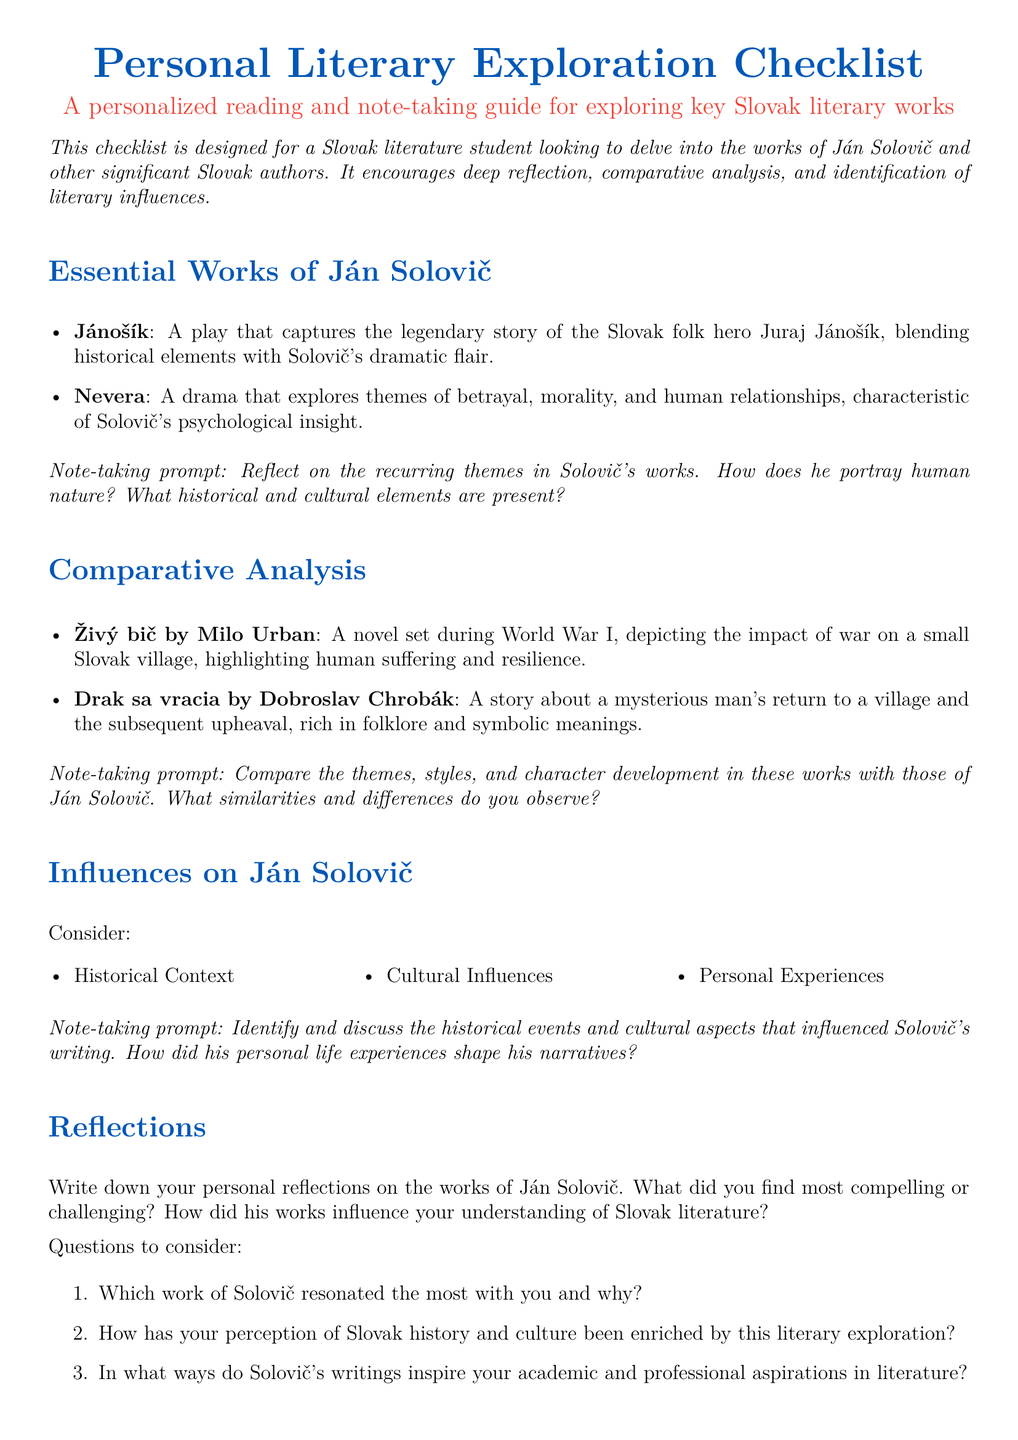What are the titles of Ján Solovič's essential works? The checklist lists two essential works by Ján Solovič: "Jánošík" and "Nevera."
Answer: "Jánošík, Nevera" What themes does "Nevera" explore? The checklist mentions that "Nevera" explores themes of betrayal, morality, and human relationships.
Answer: Betrayal, morality, human relationships Who is the author of "Živý bič"? The checklist provides the name of the author of "Živý bič," which is Milo Urban.
Answer: Milo Urban What historical event is the backdrop for "Živý bič"? The checklist indicates that "Živý bič" is set during World War I.
Answer: World War I What type of literary work is "Drak sa vracia"? The checklist states that "Drak sa vracia" is a story.
Answer: Story What influences on Ján Solovič should you consider? The checklist suggests considering historical context, cultural influences, and personal experiences.
Answer: Historical context, cultural influences, personal experiences Which reflection question asks about Solovič’s influence? The checklist includes a question about how Solovič's writings inspire academic and professional aspirations.
Answer: In what ways do Solovič's writings inspire your academic and professional aspirations in literature? What is a note-taking prompt for comparing works? The checklist provides a note-taking prompt asking to compare the themes, styles, and character development in the works.
Answer: Compare the themes, styles, and character development in these works with those of Ján Solovič 